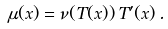Convert formula to latex. <formula><loc_0><loc_0><loc_500><loc_500>\mu ( x ) = \nu ( T ( x ) ) \, T ^ { \prime } ( x ) \, .</formula> 